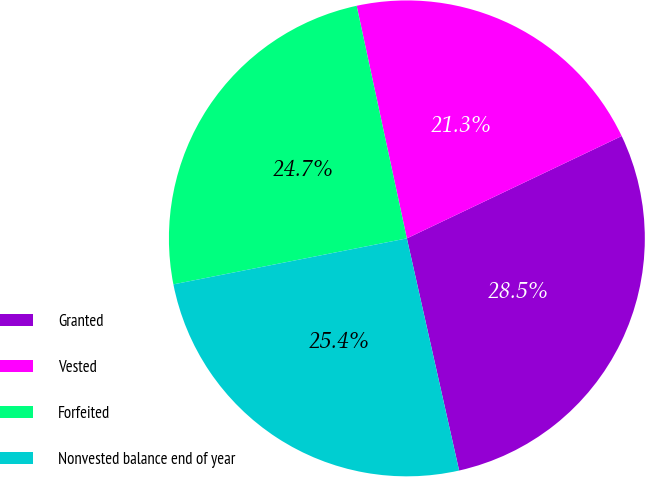Convert chart to OTSL. <chart><loc_0><loc_0><loc_500><loc_500><pie_chart><fcel>Granted<fcel>Vested<fcel>Forfeited<fcel>Nonvested balance end of year<nl><fcel>28.55%<fcel>21.31%<fcel>24.71%<fcel>25.43%<nl></chart> 